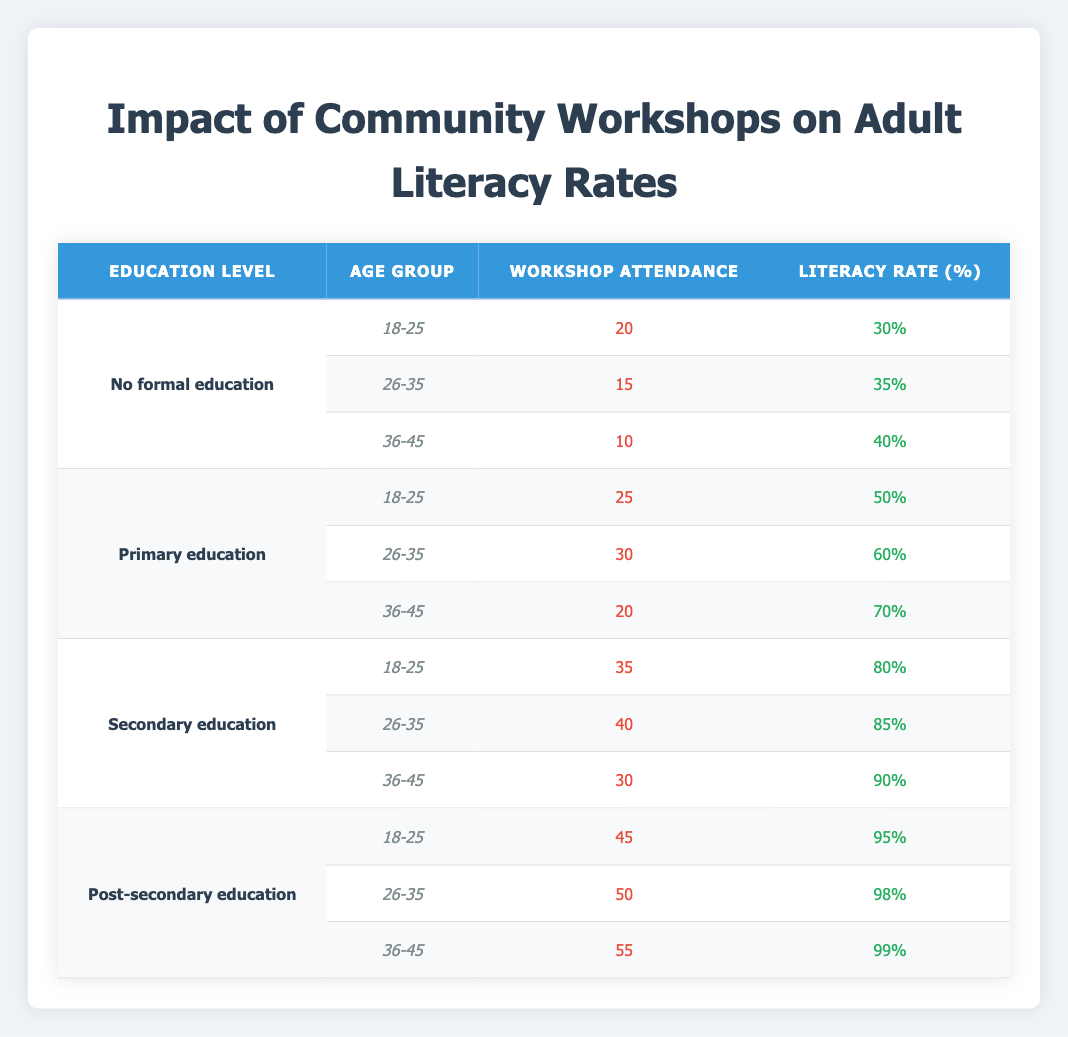What is the literacy rate for individuals aged 26-35 with primary education? The table shows that for the age group 26-35 under the education level of primary education, the literacy rate is listed as 60%.
Answer: 60% What is the workshop attendance for individuals aged 18-25 with secondary education? For the age group 18-25 and the education level of secondary education, the workshop attendance is shown to be 35.
Answer: 35 Is the literacy rate for individuals aged 36-45 with no formal education above 40%? According to the table, the literacy rate for the age group 36-45 with no formal education is 40%, which means it is not above 40%.
Answer: No What is the combined workshop attendance for all age groups with post-secondary education? The table provides workshop attendance values for post-secondary education across three age groups: 45 (18-25) + 50 (26-35) + 55 (36-45) = 150.
Answer: 150 Which age group has the highest literacy rate among individuals with secondary education? By analyzing the table, the age group 36-45 with secondary education has the highest literacy rate of 90%, compared to 80% (18-25) and 85% (26-35).
Answer: 36-45 What is the average literacy rate for all age groups who attended workshops with no formal education? The literacy rates for individuals with no formal education across the age groups are 30% (18-25), 35% (26-35), and 40% (36-45). The sum is 30 + 35 + 40 = 105, and there are 3 groups, so the average is 105 / 3 = 35%.
Answer: 35% Have the literacy rates increased as the educational level rises across all age groups? Reviewing the table confirms that as the education level progresses from no formal education to post-secondary education, literacy rates consistently increase: 30% to 99%.
Answer: Yes What is the difference in workshop attendance between individuals aged 26-35 with primary education and those with secondary education? For primary education, the workshop attendance for the 26-35 age group is 30. For secondary education, it is 40. The difference is 40 - 30 = 10.
Answer: 10 Which education level has the lowest literacy rate, and what is that rate? Scanning the table, no formal education has the lowest literacy rate of 30% for the age group 18-25.
Answer: No formal education, 30% 